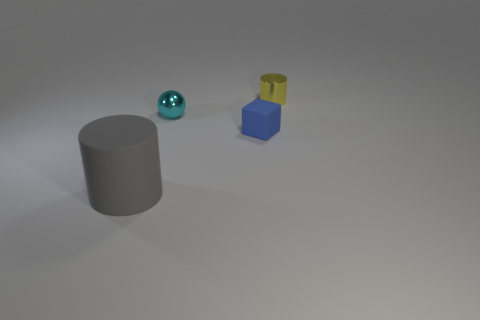Add 2 gray rubber objects. How many objects exist? 6 Subtract all gray cubes. Subtract all brown spheres. How many cubes are left? 1 Subtract all balls. How many objects are left? 3 Subtract all small cubes. Subtract all small yellow cylinders. How many objects are left? 2 Add 1 small metal cylinders. How many small metal cylinders are left? 2 Add 3 yellow metal objects. How many yellow metal objects exist? 4 Subtract 0 blue cylinders. How many objects are left? 4 